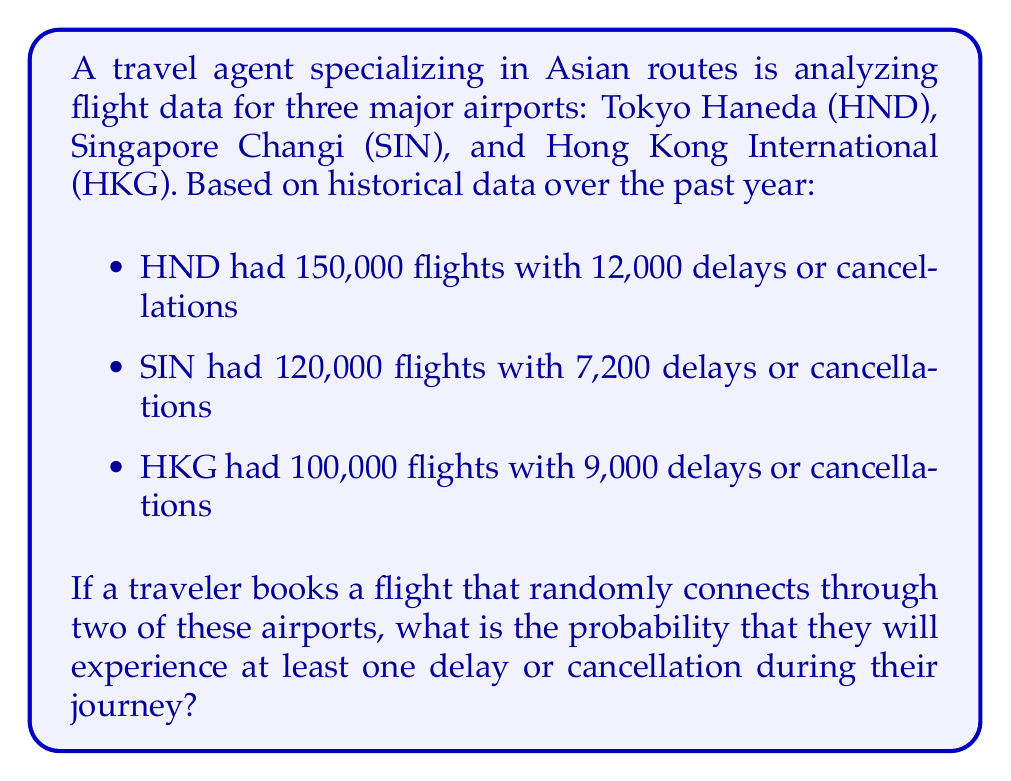Solve this math problem. To solve this problem, we'll follow these steps:

1. Calculate the probability of a delay or cancellation for each airport.
2. Calculate the probability of no delays or cancellations for each airport.
3. Use the complement rule to find the probability of at least one delay or cancellation.

Step 1: Probability of delay or cancellation for each airport

$P(\text{HND delay/cancel}) = \frac{12,000}{150,000} = 0.08$
$P(\text{SIN delay/cancel}) = \frac{7,200}{120,000} = 0.06$
$P(\text{HKG delay/cancel}) = \frac{9,000}{100,000} = 0.09$

Step 2: Probability of no delay or cancellation for each airport

$P(\text{HND on time}) = 1 - 0.08 = 0.92$
$P(\text{SIN on time}) = 1 - 0.06 = 0.94$
$P(\text{HKG on time}) = 1 - 0.09 = 0.91$

Step 3: Probability of at least one delay or cancellation

There are three possible combinations of two airports:
1. HND and SIN
2. HND and HKG
3. SIN and HKG

We need to calculate the probability of no delays or cancellations for each combination and then subtract from 1 to get the probability of at least one delay or cancellation.

$P(\text{no delay/cancel HND and SIN}) = 0.92 \times 0.94 = 0.8648$
$P(\text{no delay/cancel HND and HKG}) = 0.92 \times 0.91 = 0.8372$
$P(\text{no delay/cancel SIN and HKG}) = 0.94 \times 0.91 = 0.8554$

The average probability of no delays or cancellations:

$P(\text{no delay/cancel}) = \frac{0.8648 + 0.8372 + 0.8554}{3} = 0.8525$

Therefore, the probability of at least one delay or cancellation:

$P(\text{at least one delay/cancel}) = 1 - P(\text{no delay/cancel}) = 1 - 0.8525 = 0.1475$
Answer: The probability that a traveler will experience at least one delay or cancellation during their journey through two randomly selected airports is approximately 0.1475 or 14.75%. 